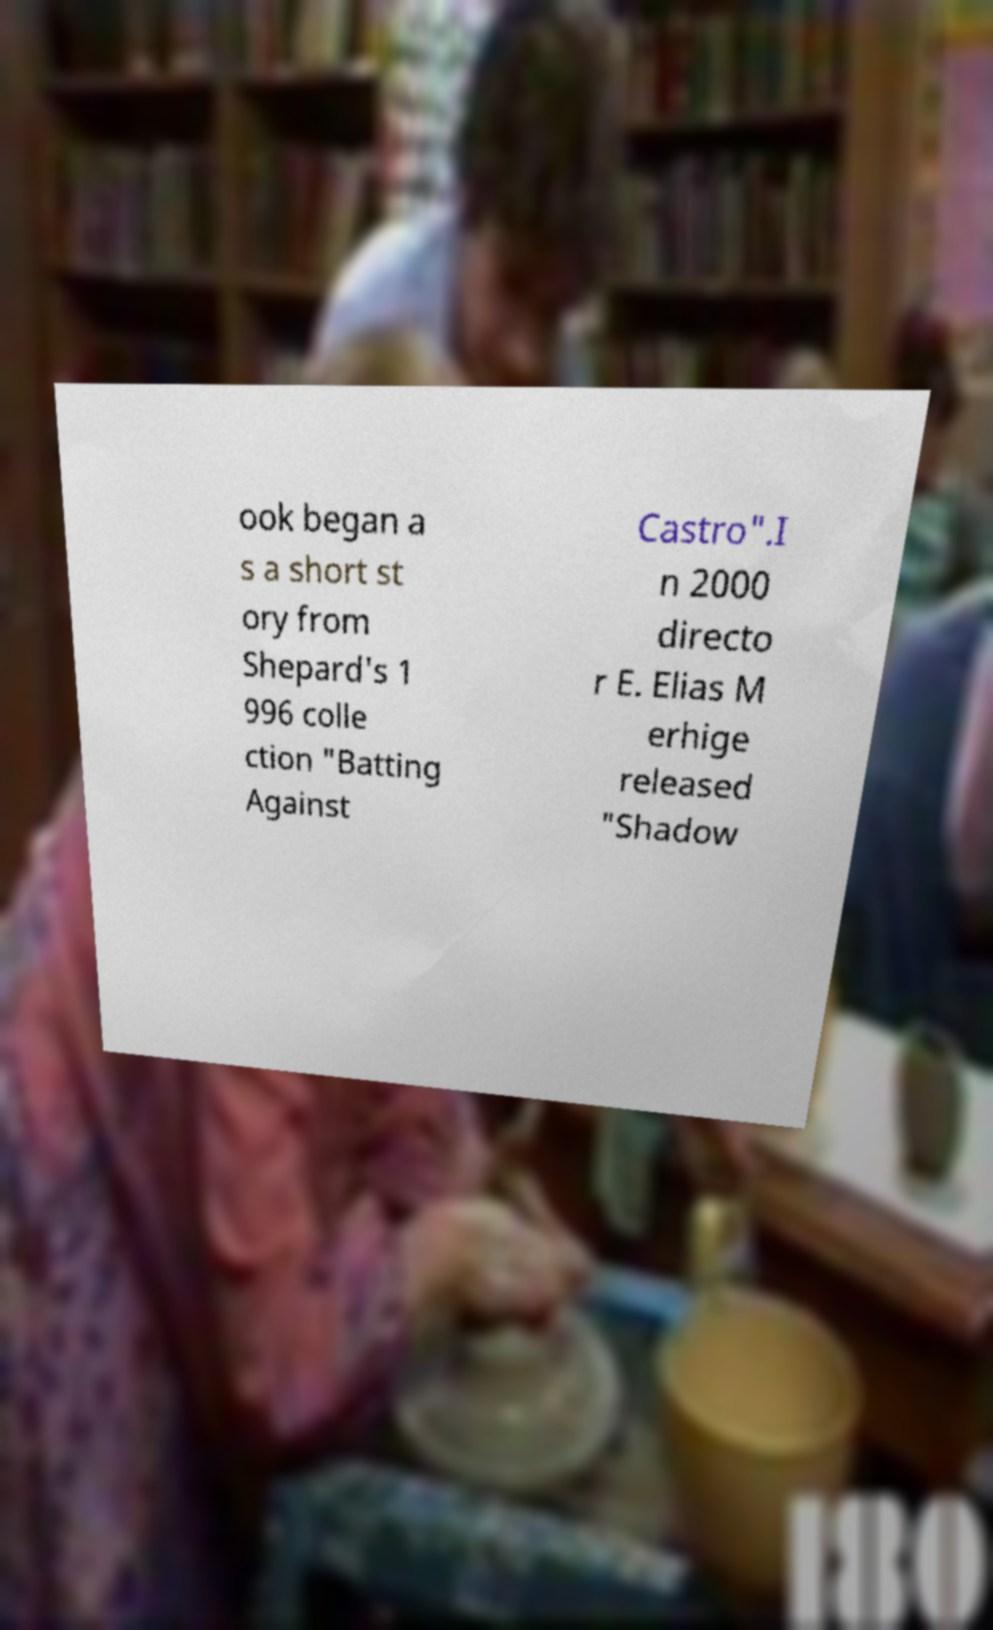Can you accurately transcribe the text from the provided image for me? ook began a s a short st ory from Shepard's 1 996 colle ction "Batting Against Castro".I n 2000 directo r E. Elias M erhige released "Shadow 